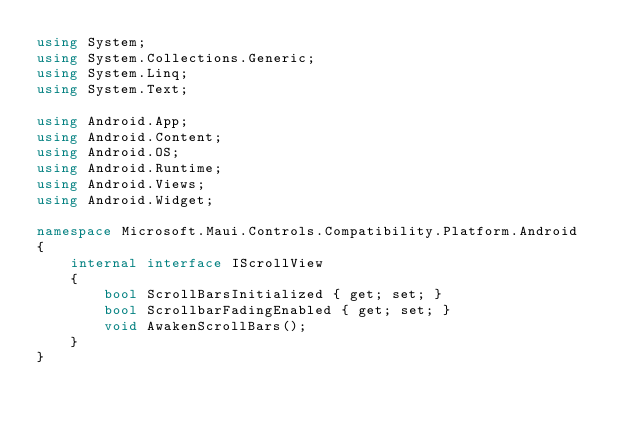<code> <loc_0><loc_0><loc_500><loc_500><_C#_>using System;
using System.Collections.Generic;
using System.Linq;
using System.Text;

using Android.App;
using Android.Content;
using Android.OS;
using Android.Runtime;
using Android.Views;
using Android.Widget;

namespace Microsoft.Maui.Controls.Compatibility.Platform.Android
{
	internal interface IScrollView
	{
		bool ScrollBarsInitialized { get; set; }
		bool ScrollbarFadingEnabled { get; set; }
		void AwakenScrollBars();
	}
}</code> 